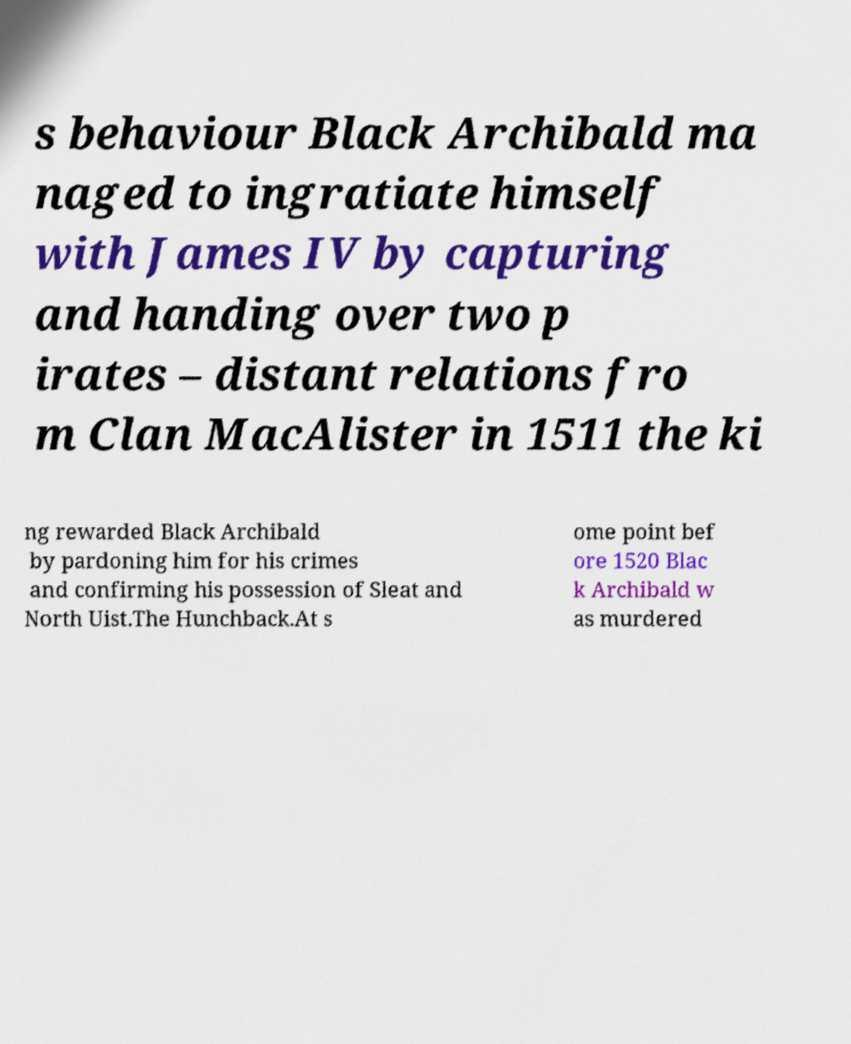Can you accurately transcribe the text from the provided image for me? s behaviour Black Archibald ma naged to ingratiate himself with James IV by capturing and handing over two p irates – distant relations fro m Clan MacAlister in 1511 the ki ng rewarded Black Archibald by pardoning him for his crimes and confirming his possession of Sleat and North Uist.The Hunchback.At s ome point bef ore 1520 Blac k Archibald w as murdered 